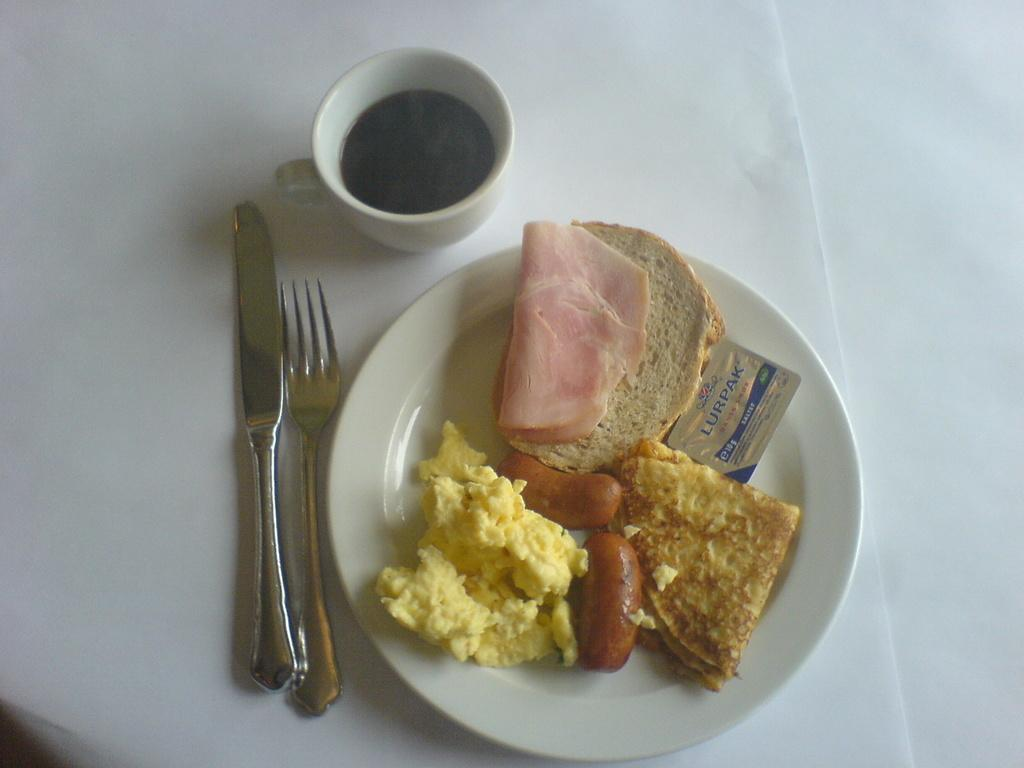What is on the plate that is visible in the image? There is food on a plate in the image. What utensil is located beside the plate? There is a fork beside the plate. What type of object is beside the plate, other than the fork? There is a steel object beside the plate. What is the color of the surface beneath the plate? The surface beneath the plate is white. How many grapes are in the jail in the image? There are no grapes or jails present in the image. 